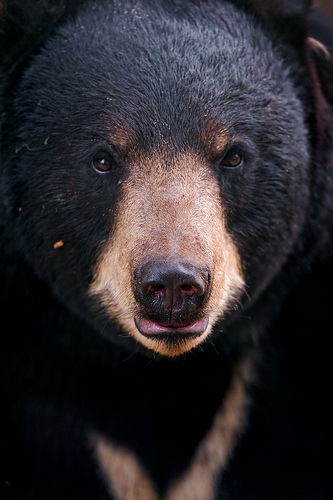Please provide a short description for this region: [0.37, 0.23, 0.45, 0.29]. The region within the coordinates [0.37, 0.23, 0.45, 0.29] shows a tan eyebrow on the bear. This light-colored fur above the eye contrasts with the surrounding darker fur, highlighting the bear's expressive feature. 